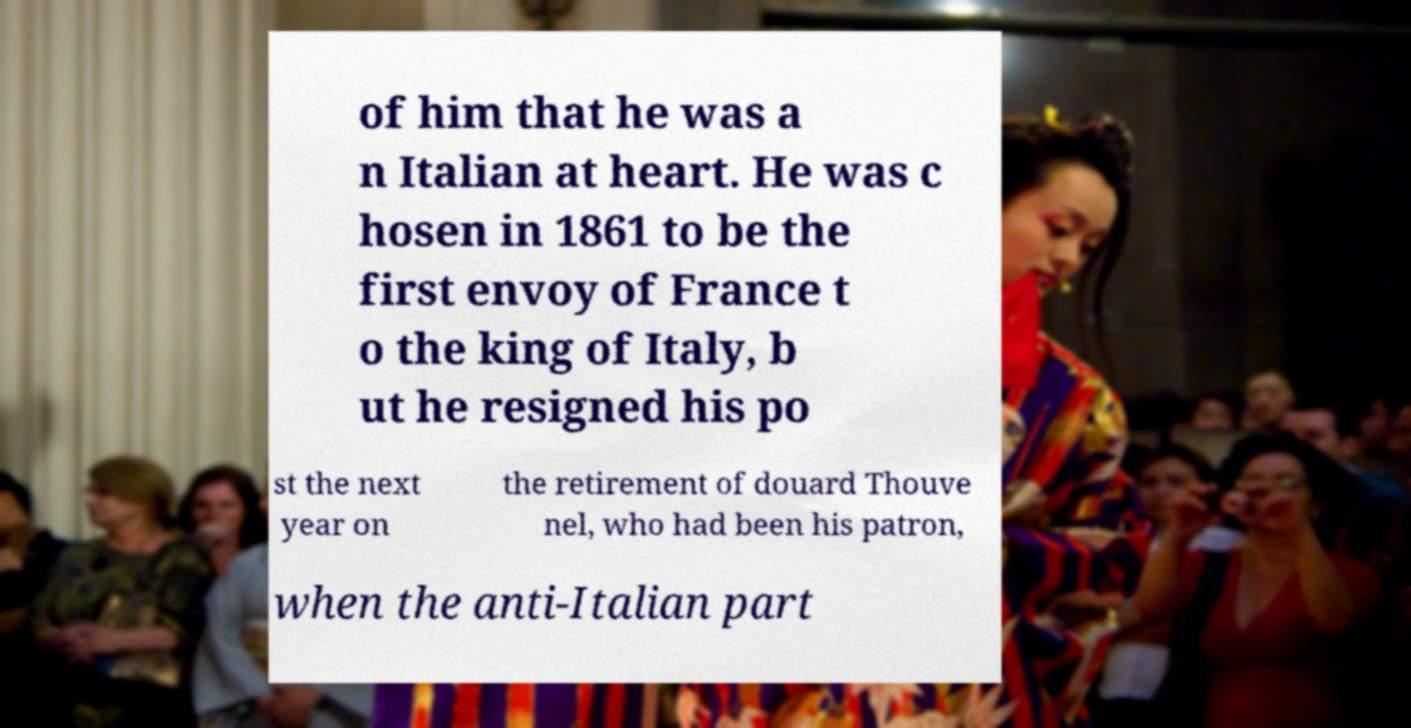Can you accurately transcribe the text from the provided image for me? of him that he was a n Italian at heart. He was c hosen in 1861 to be the first envoy of France t o the king of Italy, b ut he resigned his po st the next year on the retirement of douard Thouve nel, who had been his patron, when the anti-Italian part 